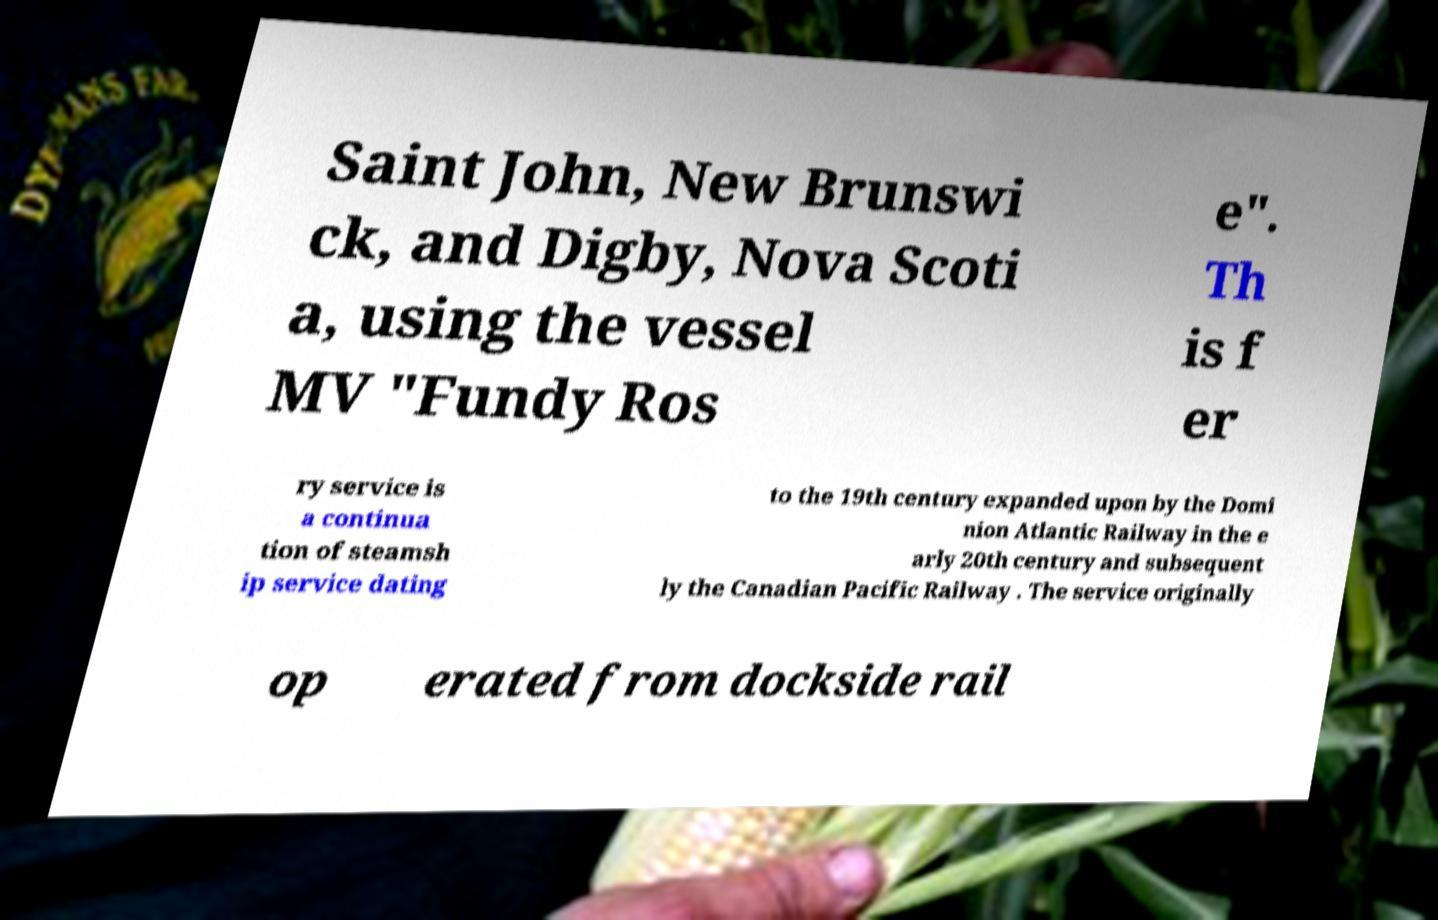Please identify and transcribe the text found in this image. Saint John, New Brunswi ck, and Digby, Nova Scoti a, using the vessel MV "Fundy Ros e". Th is f er ry service is a continua tion of steamsh ip service dating to the 19th century expanded upon by the Domi nion Atlantic Railway in the e arly 20th century and subsequent ly the Canadian Pacific Railway . The service originally op erated from dockside rail 